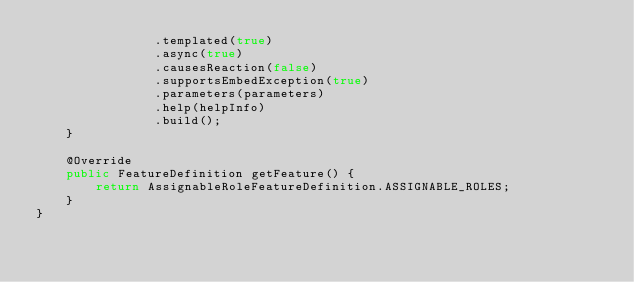<code> <loc_0><loc_0><loc_500><loc_500><_Java_>                .templated(true)
                .async(true)
                .causesReaction(false)
                .supportsEmbedException(true)
                .parameters(parameters)
                .help(helpInfo)
                .build();
    }

    @Override
    public FeatureDefinition getFeature() {
        return AssignableRoleFeatureDefinition.ASSIGNABLE_ROLES;
    }
}
</code> 